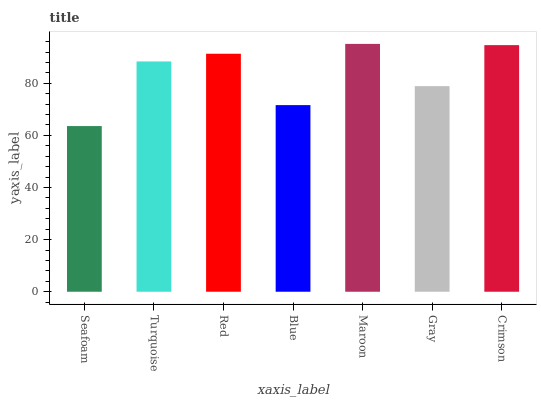Is Seafoam the minimum?
Answer yes or no. Yes. Is Maroon the maximum?
Answer yes or no. Yes. Is Turquoise the minimum?
Answer yes or no. No. Is Turquoise the maximum?
Answer yes or no. No. Is Turquoise greater than Seafoam?
Answer yes or no. Yes. Is Seafoam less than Turquoise?
Answer yes or no. Yes. Is Seafoam greater than Turquoise?
Answer yes or no. No. Is Turquoise less than Seafoam?
Answer yes or no. No. Is Turquoise the high median?
Answer yes or no. Yes. Is Turquoise the low median?
Answer yes or no. Yes. Is Red the high median?
Answer yes or no. No. Is Seafoam the low median?
Answer yes or no. No. 